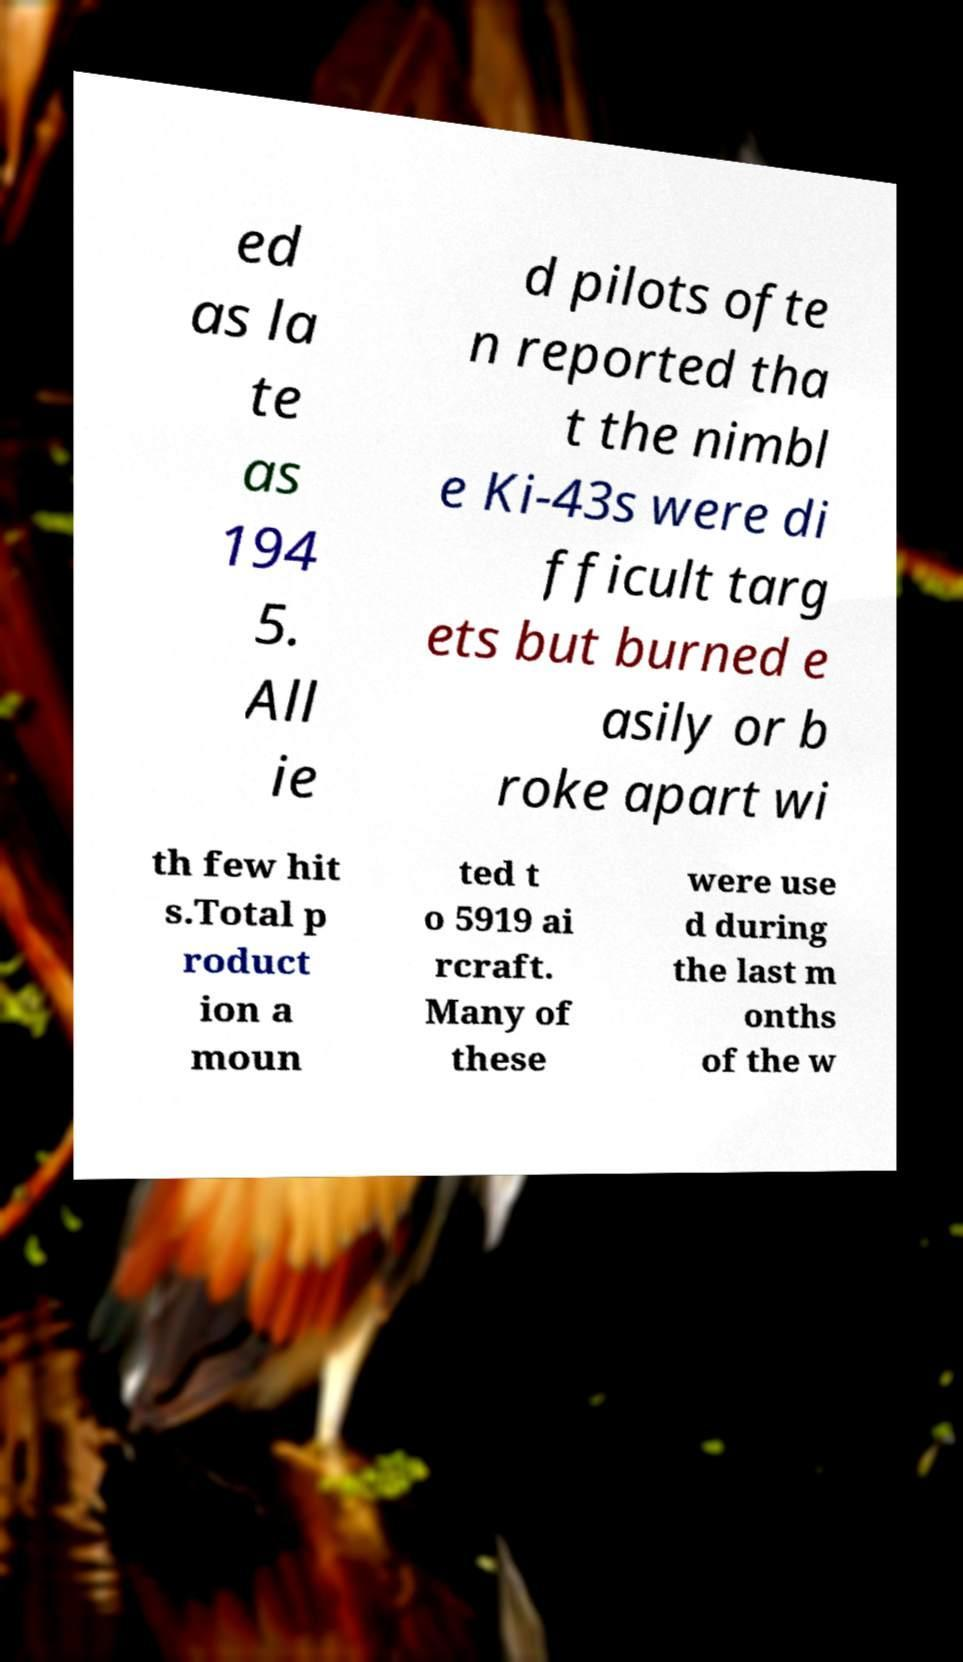For documentation purposes, I need the text within this image transcribed. Could you provide that? ed as la te as 194 5. All ie d pilots ofte n reported tha t the nimbl e Ki-43s were di fficult targ ets but burned e asily or b roke apart wi th few hit s.Total p roduct ion a moun ted t o 5919 ai rcraft. Many of these were use d during the last m onths of the w 